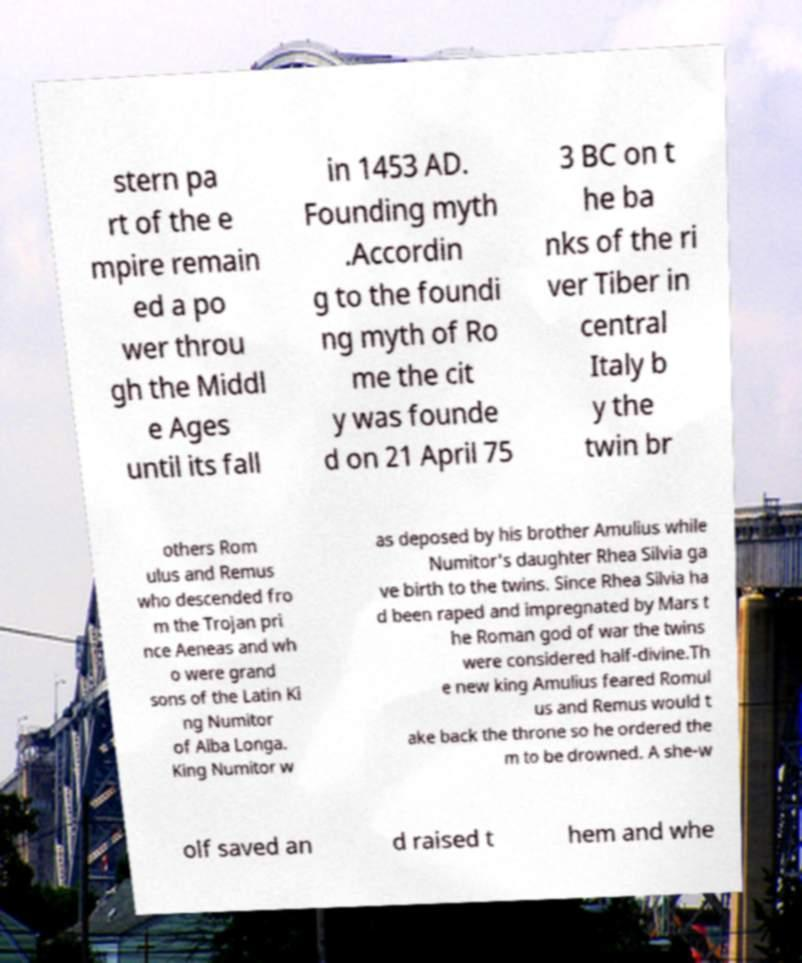What messages or text are displayed in this image? I need them in a readable, typed format. stern pa rt of the e mpire remain ed a po wer throu gh the Middl e Ages until its fall in 1453 AD. Founding myth .Accordin g to the foundi ng myth of Ro me the cit y was founde d on 21 April 75 3 BC on t he ba nks of the ri ver Tiber in central Italy b y the twin br others Rom ulus and Remus who descended fro m the Trojan pri nce Aeneas and wh o were grand sons of the Latin Ki ng Numitor of Alba Longa. King Numitor w as deposed by his brother Amulius while Numitor's daughter Rhea Silvia ga ve birth to the twins. Since Rhea Silvia ha d been raped and impregnated by Mars t he Roman god of war the twins were considered half-divine.Th e new king Amulius feared Romul us and Remus would t ake back the throne so he ordered the m to be drowned. A she-w olf saved an d raised t hem and whe 